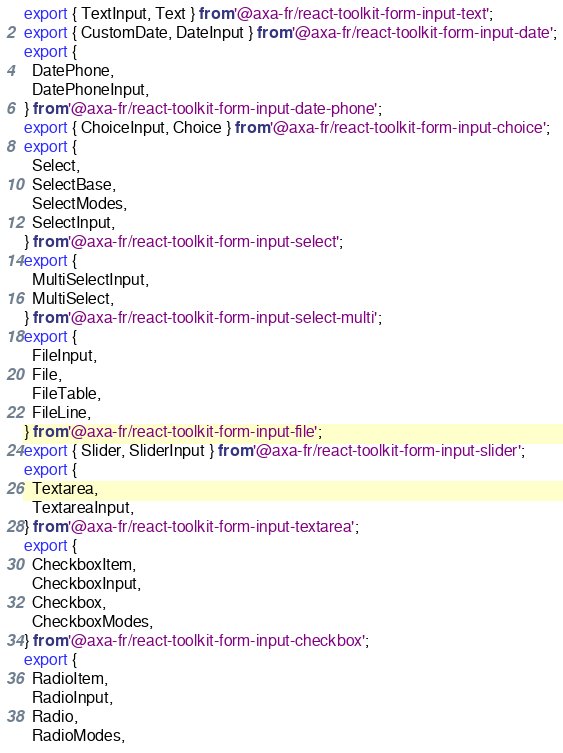<code> <loc_0><loc_0><loc_500><loc_500><_JavaScript_>export { TextInput, Text } from '@axa-fr/react-toolkit-form-input-text';
export { CustomDate, DateInput } from '@axa-fr/react-toolkit-form-input-date';
export {
  DatePhone,
  DatePhoneInput,
} from '@axa-fr/react-toolkit-form-input-date-phone';
export { ChoiceInput, Choice } from '@axa-fr/react-toolkit-form-input-choice';
export {
  Select,
  SelectBase,
  SelectModes,
  SelectInput,
} from '@axa-fr/react-toolkit-form-input-select';
export {
  MultiSelectInput,
  MultiSelect,
} from '@axa-fr/react-toolkit-form-input-select-multi';
export {
  FileInput,
  File,
  FileTable,
  FileLine,
} from '@axa-fr/react-toolkit-form-input-file';
export { Slider, SliderInput } from '@axa-fr/react-toolkit-form-input-slider';
export {
  Textarea,
  TextareaInput,
} from '@axa-fr/react-toolkit-form-input-textarea';
export {
  CheckboxItem,
  CheckboxInput,
  Checkbox,
  CheckboxModes,
} from '@axa-fr/react-toolkit-form-input-checkbox';
export {
  RadioItem,
  RadioInput,
  Radio,
  RadioModes,</code> 